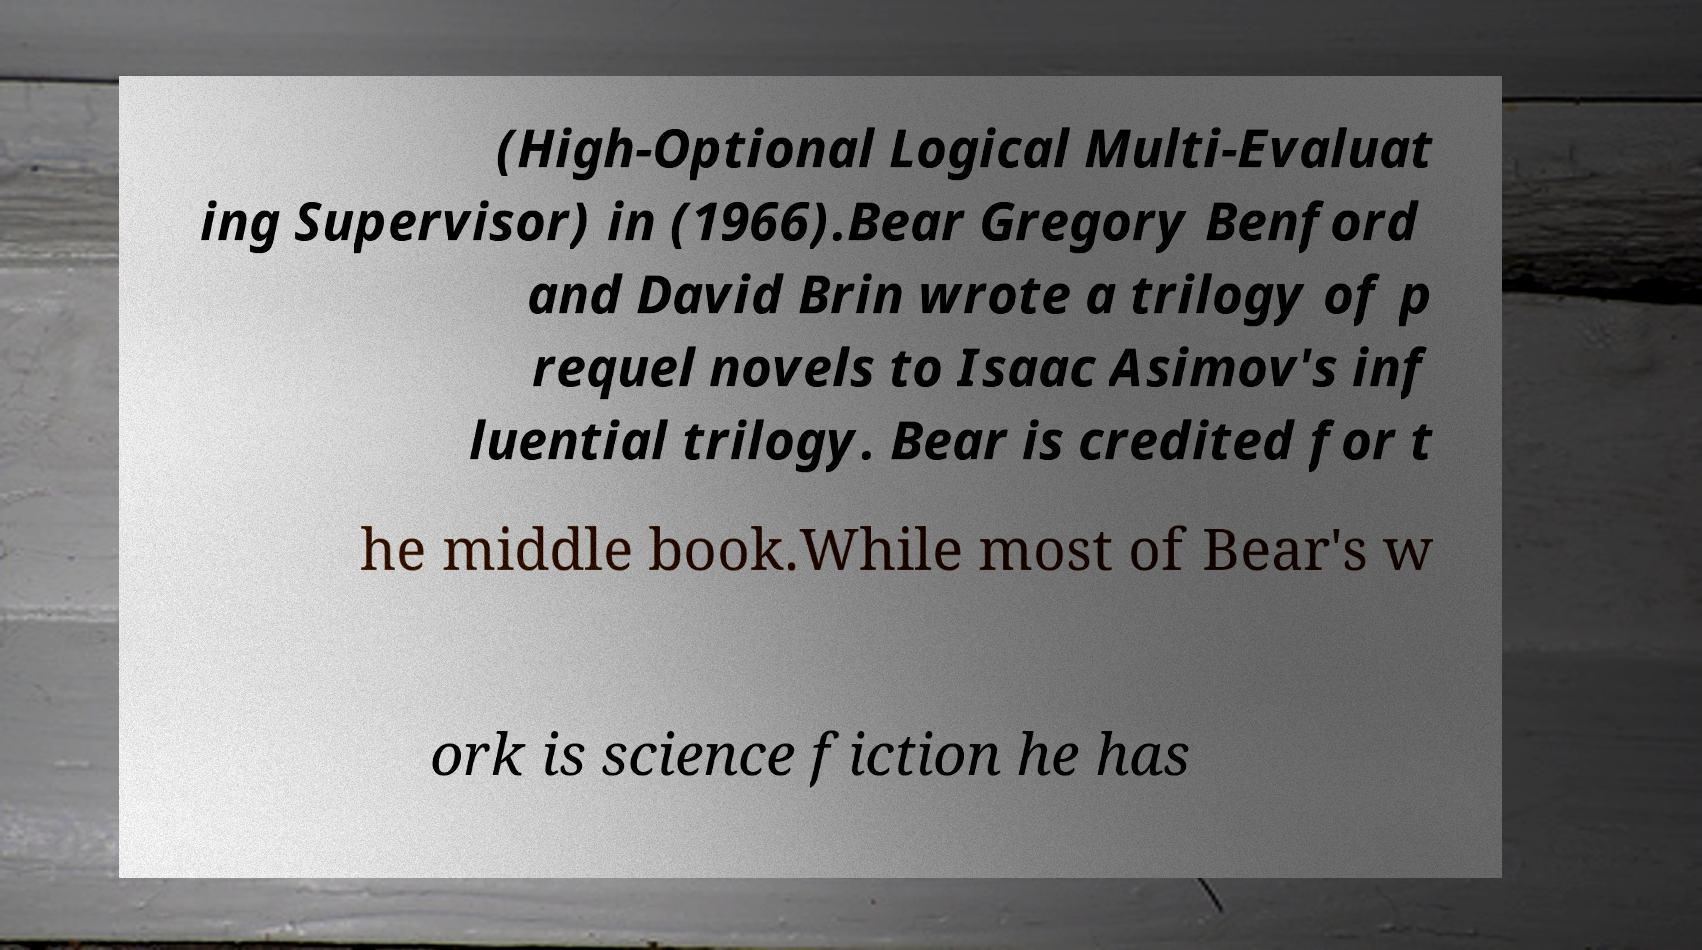I need the written content from this picture converted into text. Can you do that? (High-Optional Logical Multi-Evaluat ing Supervisor) in (1966).Bear Gregory Benford and David Brin wrote a trilogy of p requel novels to Isaac Asimov's inf luential trilogy. Bear is credited for t he middle book.While most of Bear's w ork is science fiction he has 